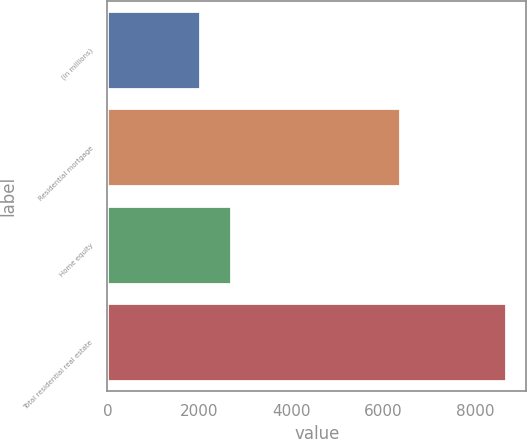<chart> <loc_0><loc_0><loc_500><loc_500><bar_chart><fcel>(in millions)<fcel>Residential mortgage<fcel>Home equity<fcel>Total residential real estate<nl><fcel>2016<fcel>6376<fcel>2683.1<fcel>8687<nl></chart> 